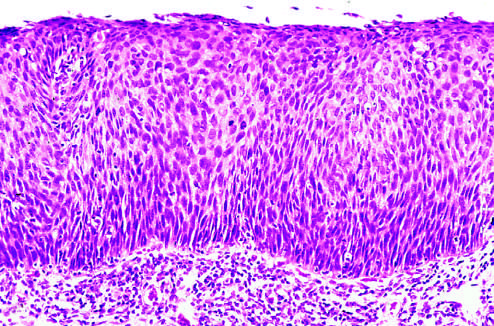s there orderly differentiation of squamous cells?
Answer the question using a single word or phrase. No 